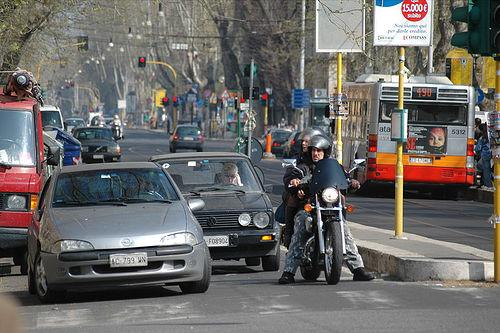Why are all the vehicles on the left not moving?

Choices:
A) tired
B) red light
C) parade
D) accident red light 